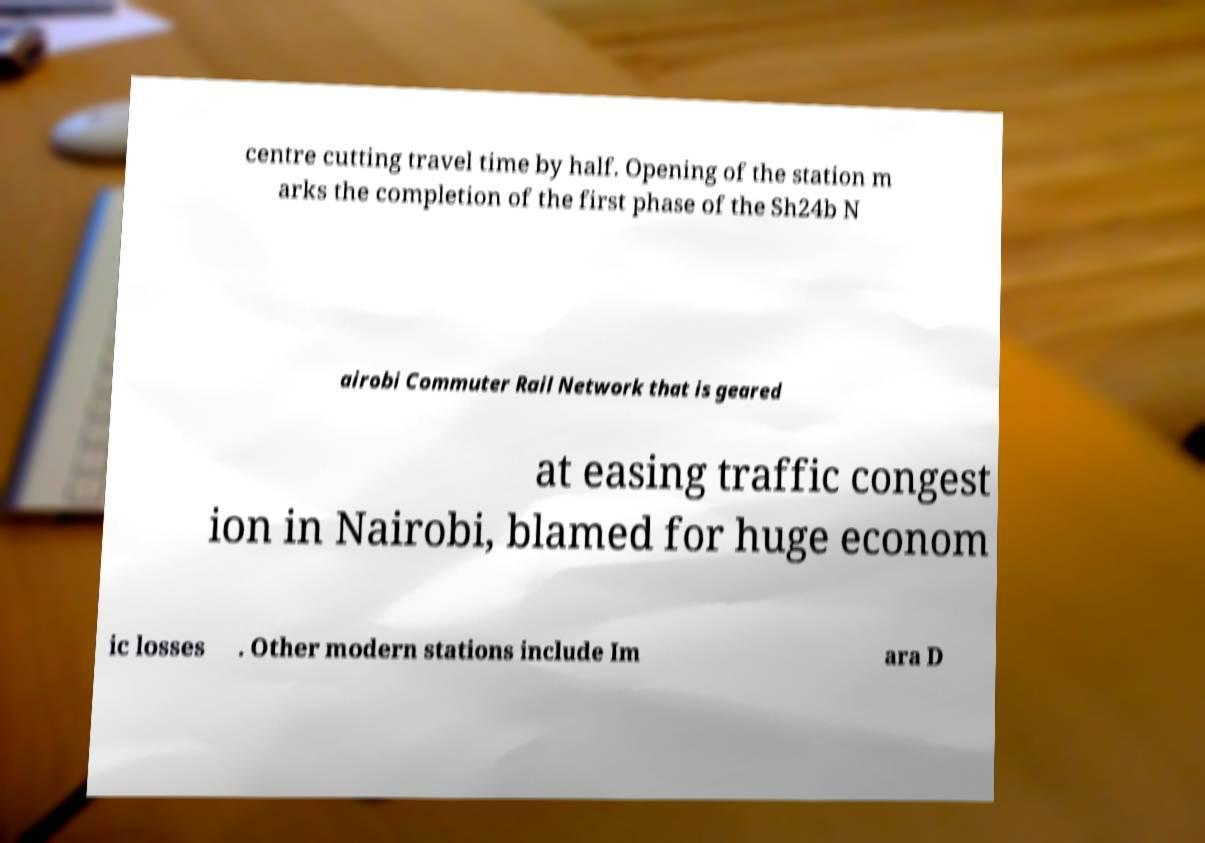There's text embedded in this image that I need extracted. Can you transcribe it verbatim? centre cutting travel time by half. Opening of the station m arks the completion of the first phase of the Sh24b N airobi Commuter Rail Network that is geared at easing traffic congest ion in Nairobi, blamed for huge econom ic losses . Other modern stations include Im ara D 